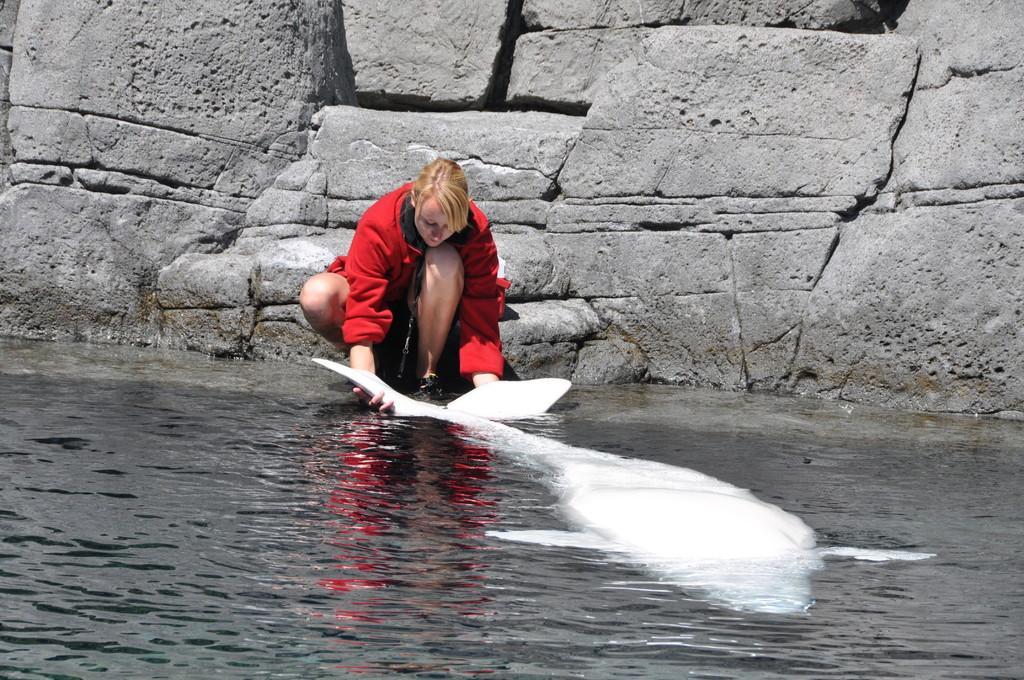Please provide a concise description of this image. In this image there is a woman who is holding the white color dolphin which is in the water. In the background there is a stone wall. The woman is wearing the red dress. 